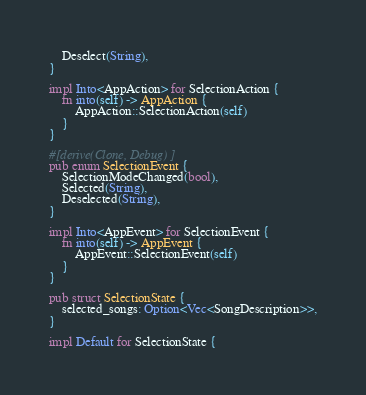<code> <loc_0><loc_0><loc_500><loc_500><_Rust_>    Deselect(String),
}

impl Into<AppAction> for SelectionAction {
    fn into(self) -> AppAction {
        AppAction::SelectionAction(self)
    }
}

#[derive(Clone, Debug)]
pub enum SelectionEvent {
    SelectionModeChanged(bool),
    Selected(String),
    Deselected(String),
}

impl Into<AppEvent> for SelectionEvent {
    fn into(self) -> AppEvent {
        AppEvent::SelectionEvent(self)
    }
}

pub struct SelectionState {
    selected_songs: Option<Vec<SongDescription>>,
}

impl Default for SelectionState {</code> 